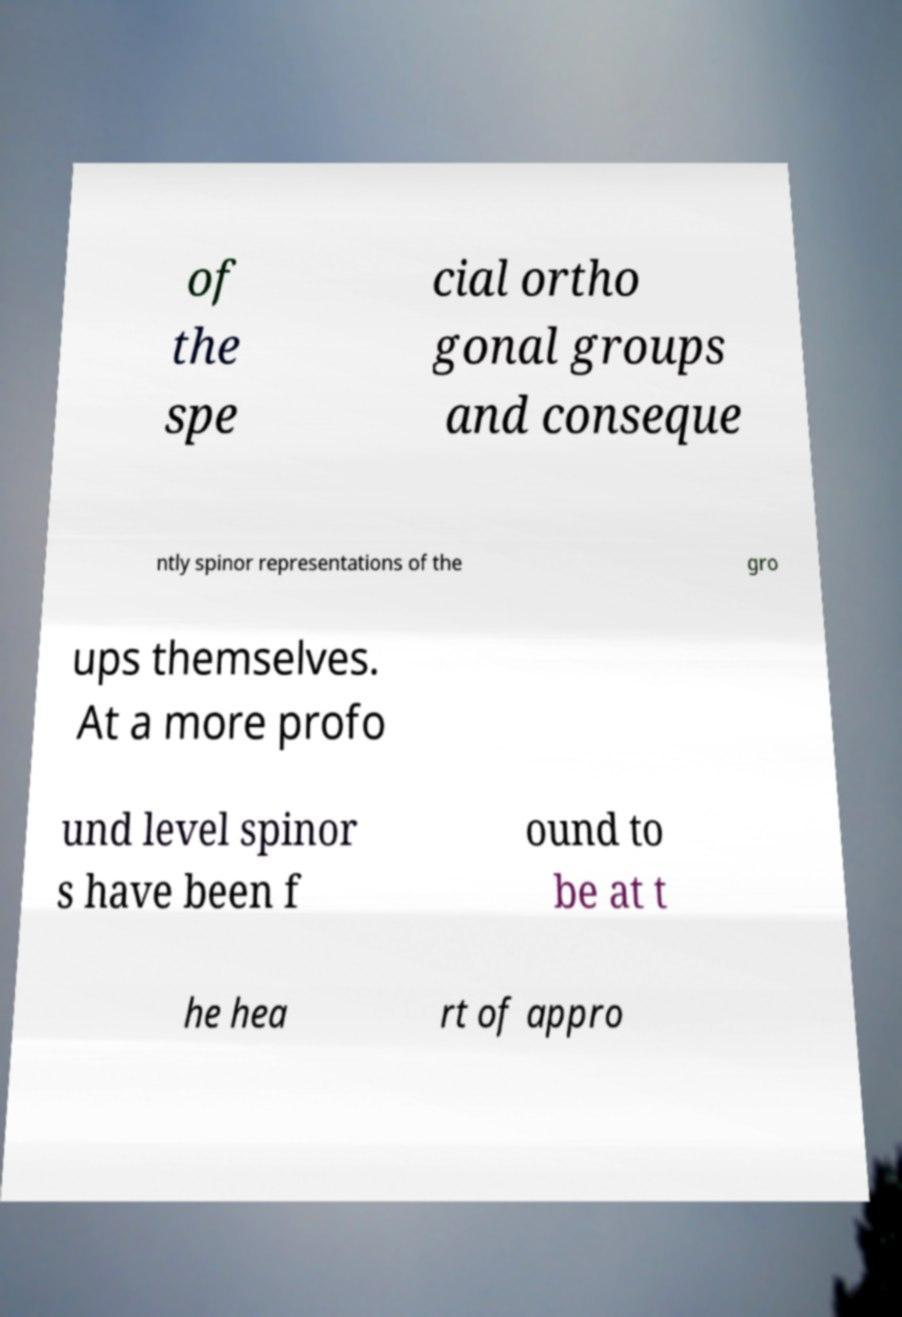Please read and relay the text visible in this image. What does it say? of the spe cial ortho gonal groups and conseque ntly spinor representations of the gro ups themselves. At a more profo und level spinor s have been f ound to be at t he hea rt of appro 